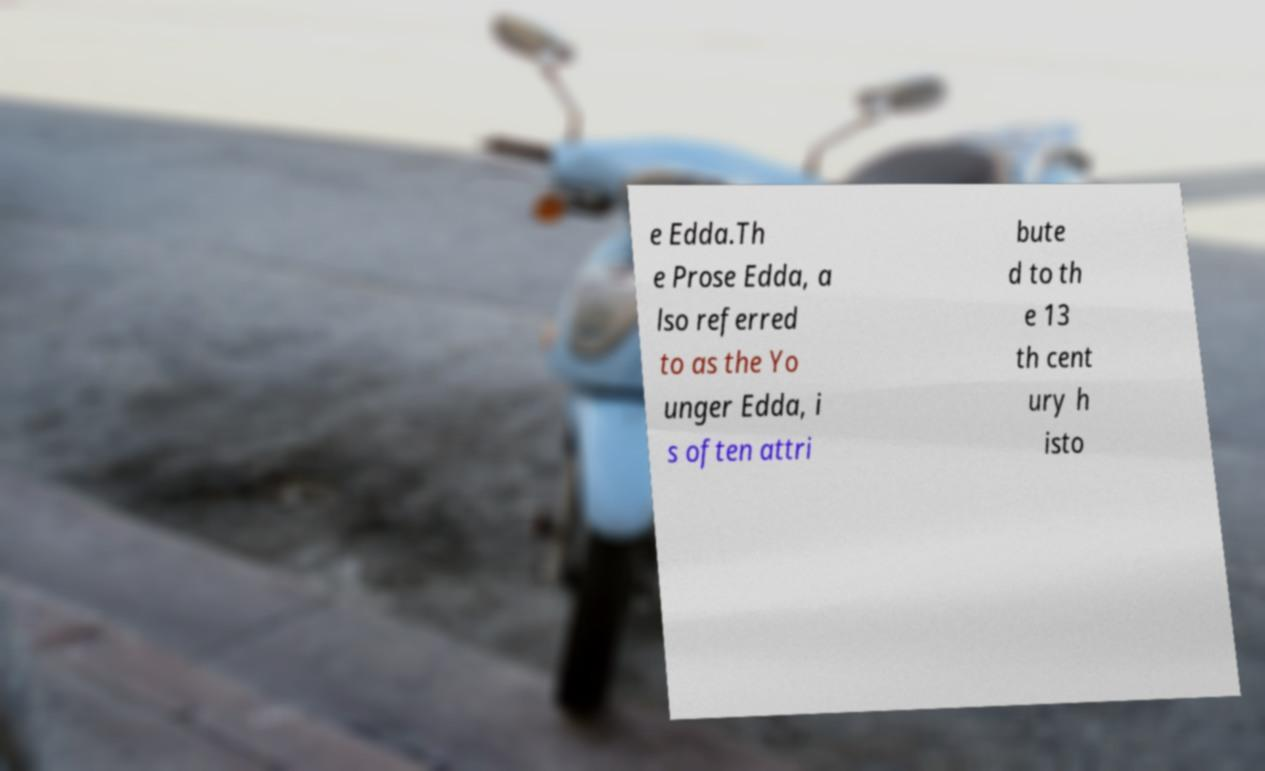Could you assist in decoding the text presented in this image and type it out clearly? e Edda.Th e Prose Edda, a lso referred to as the Yo unger Edda, i s often attri bute d to th e 13 th cent ury h isto 